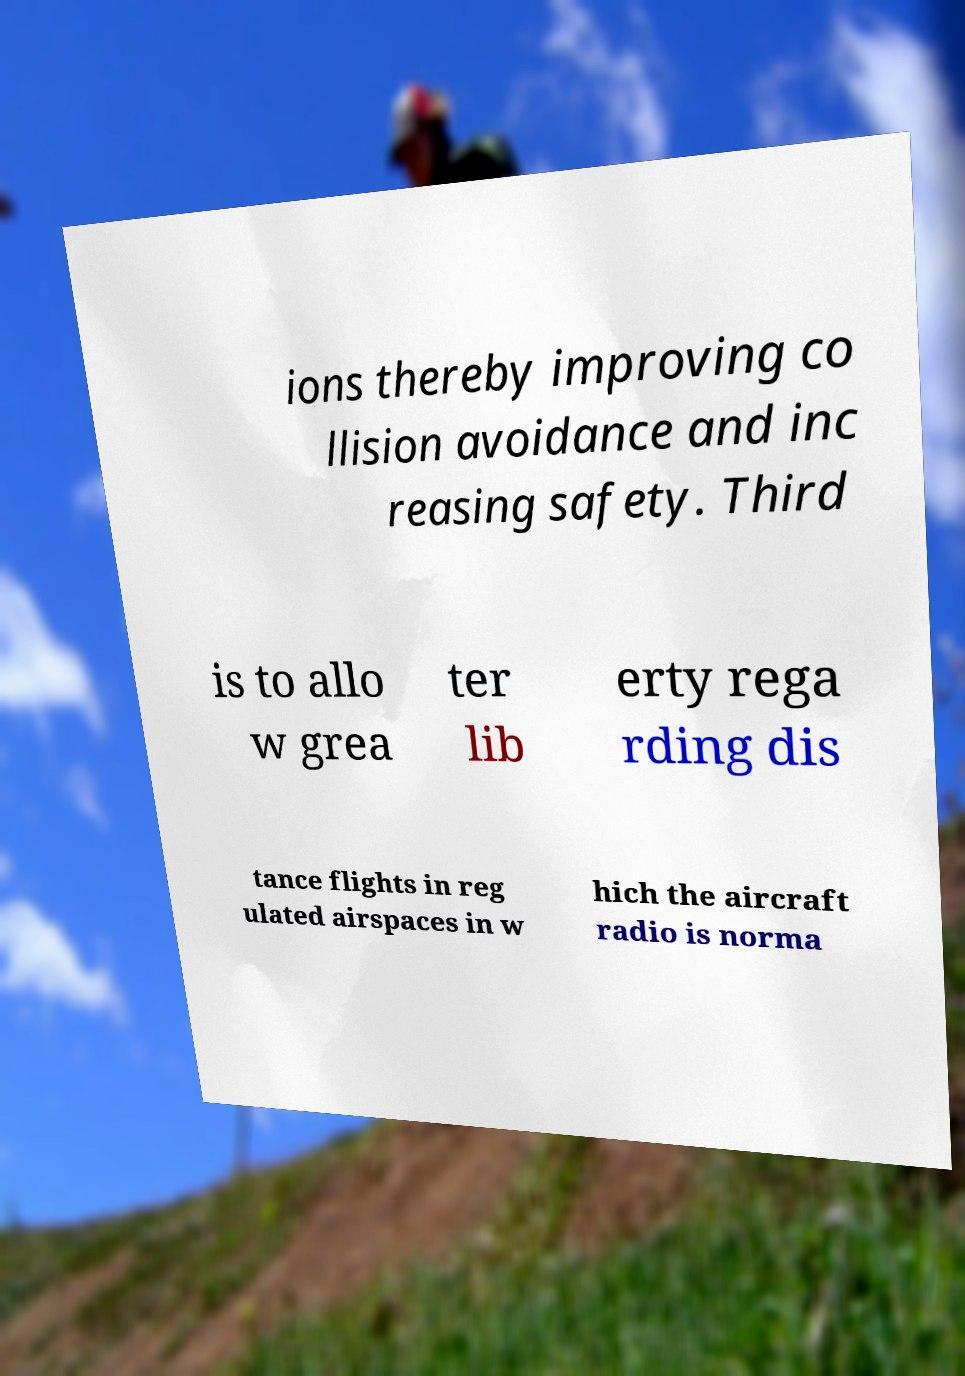Could you extract and type out the text from this image? ions thereby improving co llision avoidance and inc reasing safety. Third is to allo w grea ter lib erty rega rding dis tance flights in reg ulated airspaces in w hich the aircraft radio is norma 